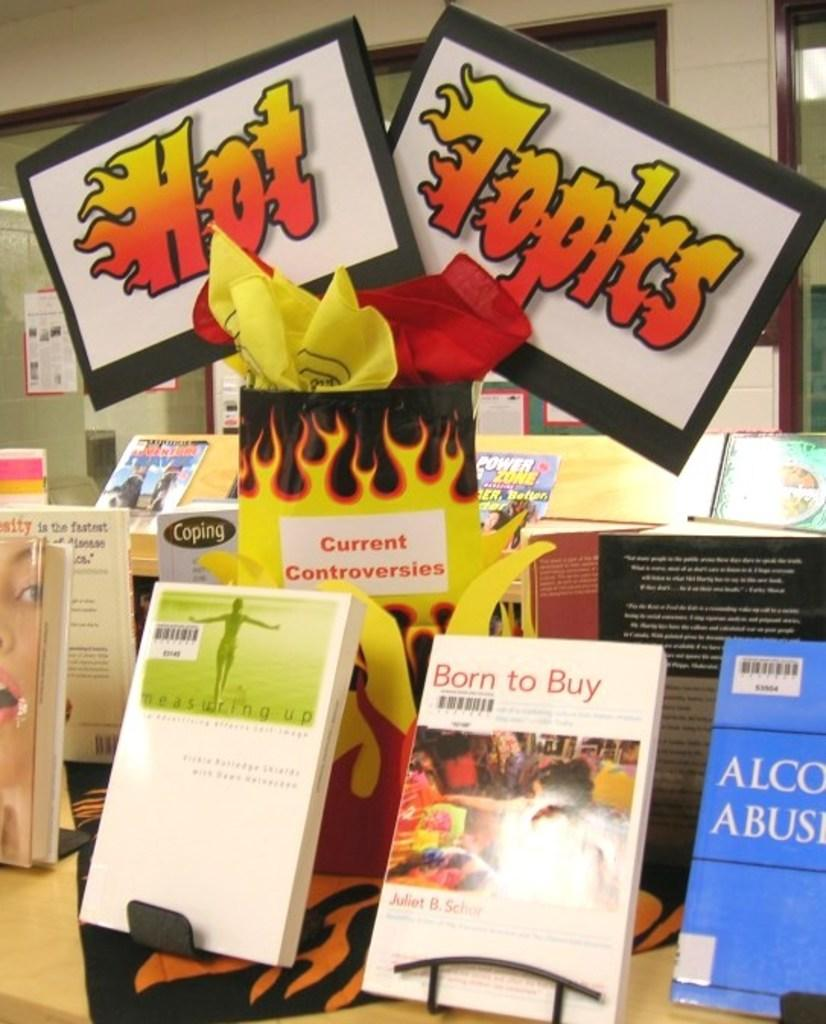<image>
Give a short and clear explanation of the subsequent image. Books are on stands displayed in a store, with a sign that says Hot topics. 